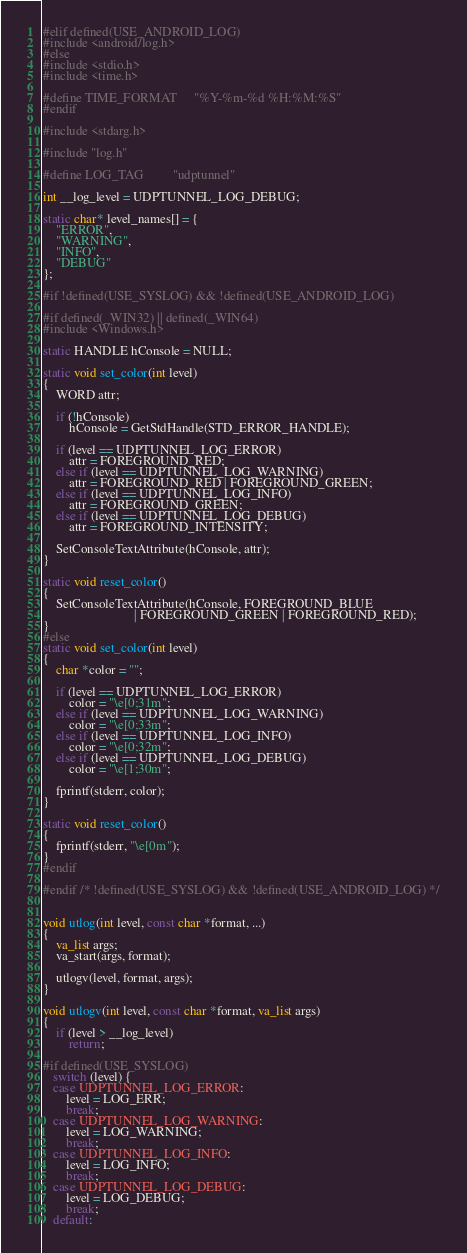<code> <loc_0><loc_0><loc_500><loc_500><_C_>#elif defined(USE_ANDROID_LOG)
#include <android/log.h>
#else
#include <stdio.h>
#include <time.h>

#define TIME_FORMAT     "%Y-%m-%d %H:%M:%S"
#endif

#include <stdarg.h>

#include "log.h"

#define LOG_TAG         "udptunnel"

int __log_level = UDPTUNNEL_LOG_DEBUG;

static char* level_names[] = {
    "ERROR",
    "WARNING",
    "INFO",
    "DEBUG"
};

#if !defined(USE_SYSLOG) && !defined(USE_ANDROID_LOG)

#if defined(_WIN32) || defined(_WIN64)
#include <Windows.h>

static HANDLE hConsole = NULL;

static void set_color(int level)
{
    WORD attr;

    if (!hConsole)
        hConsole = GetStdHandle(STD_ERROR_HANDLE);

    if (level == UDPTUNNEL_LOG_ERROR)
        attr = FOREGROUND_RED;
    else if (level == UDPTUNNEL_LOG_WARNING)
        attr = FOREGROUND_RED | FOREGROUND_GREEN;
    else if (level == UDPTUNNEL_LOG_INFO)
        attr = FOREGROUND_GREEN;
    else if (level == UDPTUNNEL_LOG_DEBUG)
        attr = FOREGROUND_INTENSITY;

    SetConsoleTextAttribute(hConsole, attr);
}

static void reset_color()
{
    SetConsoleTextAttribute(hConsole, FOREGROUND_BLUE 
                            | FOREGROUND_GREEN | FOREGROUND_RED);
}
#else
static void set_color(int level)
{
    char *color = "";

    if (level == UDPTUNNEL_LOG_ERROR)
        color = "\e[0;31m";
    else if (level == UDPTUNNEL_LOG_WARNING)
        color = "\e[0;33m";
    else if (level == UDPTUNNEL_LOG_INFO)
        color = "\e[0;32m";
    else if (level == UDPTUNNEL_LOG_DEBUG)
        color = "\e[1;30m";

    fprintf(stderr, color);
}

static void reset_color()
{
    fprintf(stderr, "\e[0m");
}
#endif

#endif /* !defined(USE_SYSLOG) && !defined(USE_ANDROID_LOG) */


void utlog(int level, const char *format, ...)
{
    va_list args;
    va_start(args, format);

    utlogv(level, format, args);
}

void utlogv(int level, const char *format, va_list args)
{
    if (level > __log_level)
        return;

#if defined(USE_SYSLOG)
   switch (level) {
   case UDPTUNNEL_LOG_ERROR:
       level = LOG_ERR;
       break;
   case UDPTUNNEL_LOG_WARNING:
       level = LOG_WARNING;
       break;
   case UDPTUNNEL_LOG_INFO:
       level = LOG_INFO;
       break;
   case UDPTUNNEL_LOG_DEBUG:
       level = LOG_DEBUG;
       break;
   default:</code> 